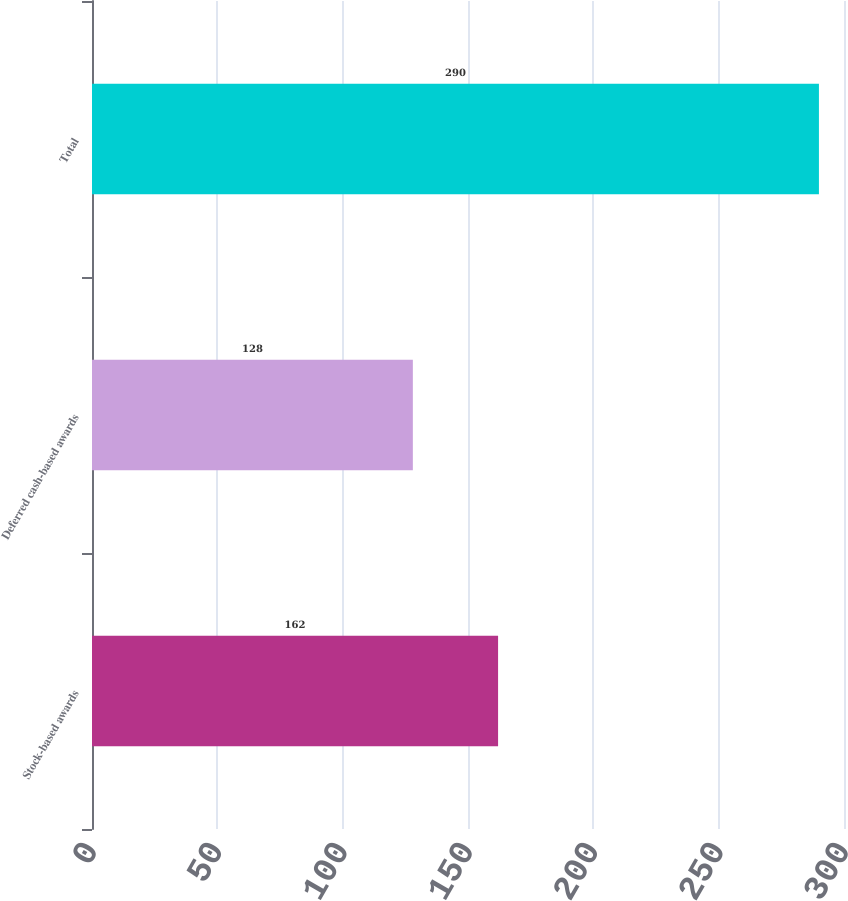<chart> <loc_0><loc_0><loc_500><loc_500><bar_chart><fcel>Stock-based awards<fcel>Deferred cash-based awards<fcel>Total<nl><fcel>162<fcel>128<fcel>290<nl></chart> 